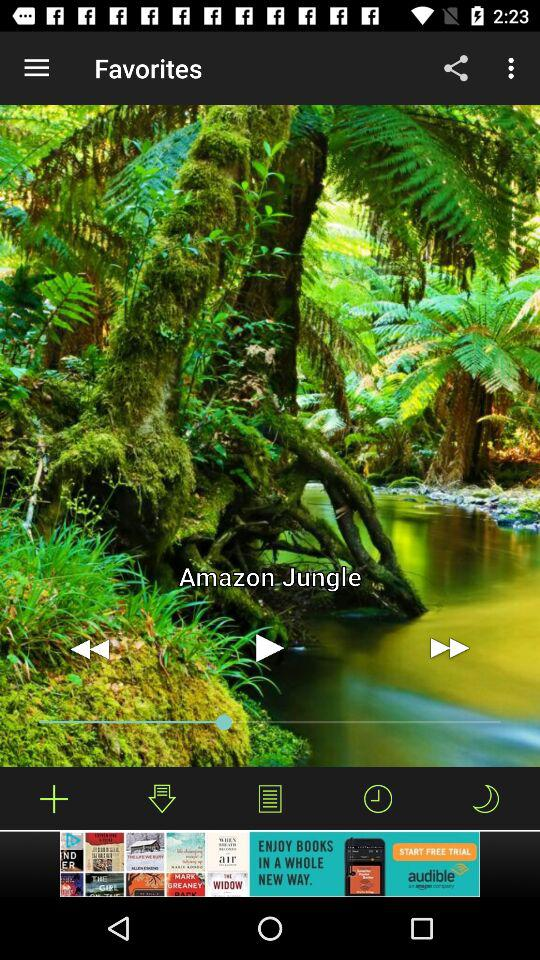What music was played? The music that was played is "Amazon Jungle". 